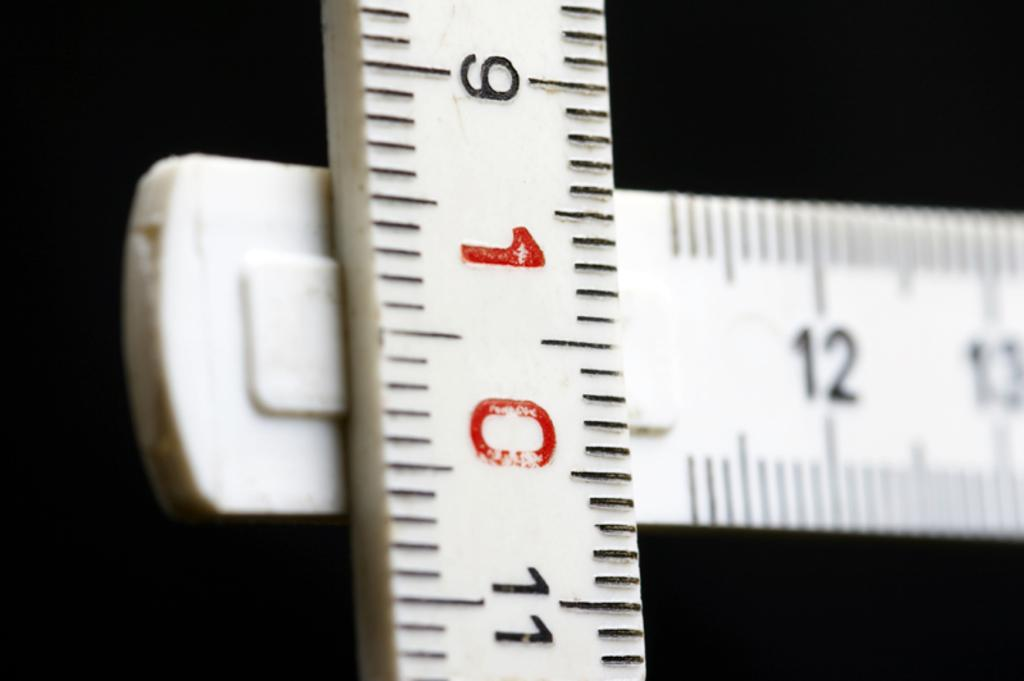<image>
Give a short and clear explanation of the subsequent image. The number in red on the white ruler is 10 